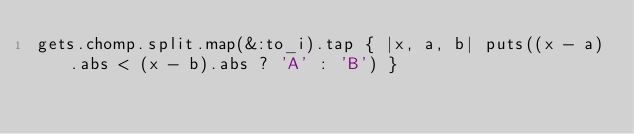Convert code to text. <code><loc_0><loc_0><loc_500><loc_500><_Ruby_>gets.chomp.split.map(&:to_i).tap { |x, a, b| puts((x - a).abs < (x - b).abs ? 'A' : 'B') }</code> 